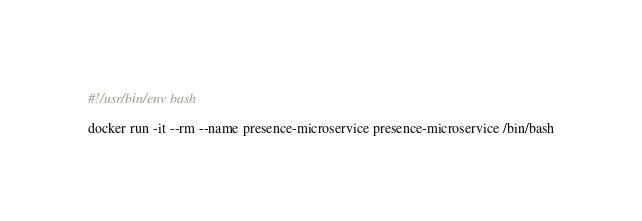Convert code to text. <code><loc_0><loc_0><loc_500><loc_500><_Bash_>#!/usr/bin/env bash

docker run -it --rm --name presence-microservice presence-microservice /bin/bash
</code> 